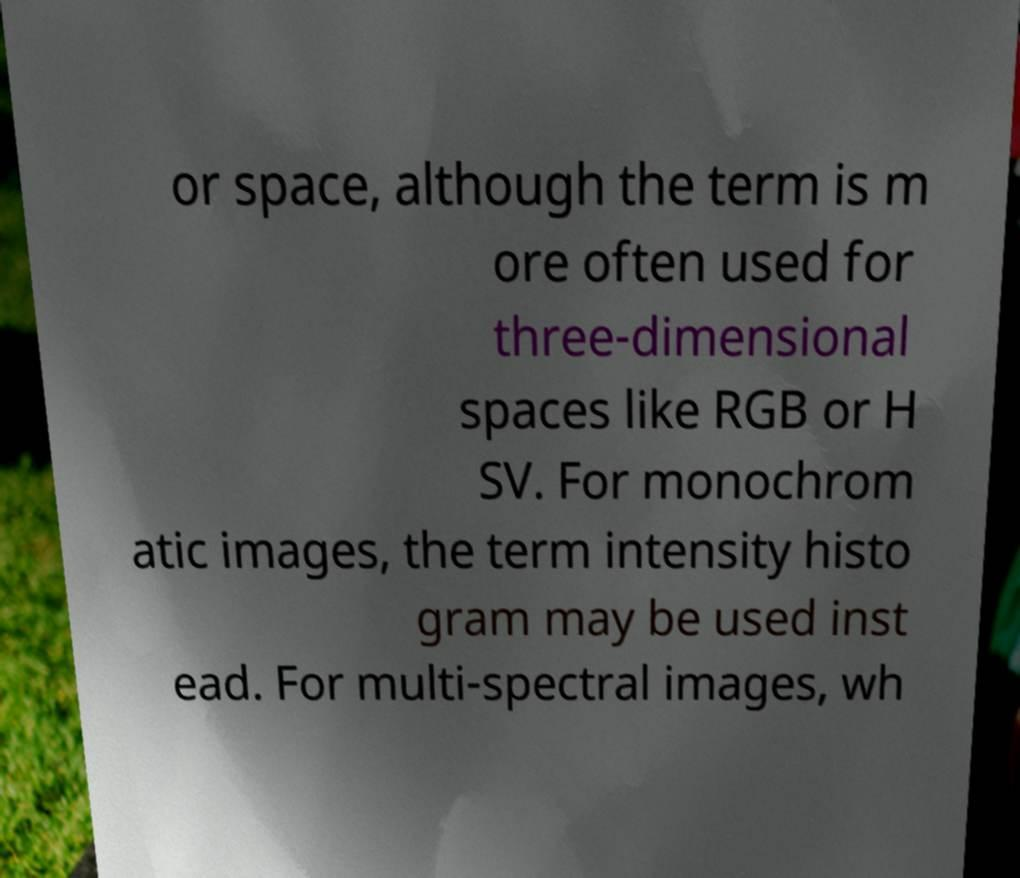There's text embedded in this image that I need extracted. Can you transcribe it verbatim? or space, although the term is m ore often used for three-dimensional spaces like RGB or H SV. For monochrom atic images, the term intensity histo gram may be used inst ead. For multi-spectral images, wh 